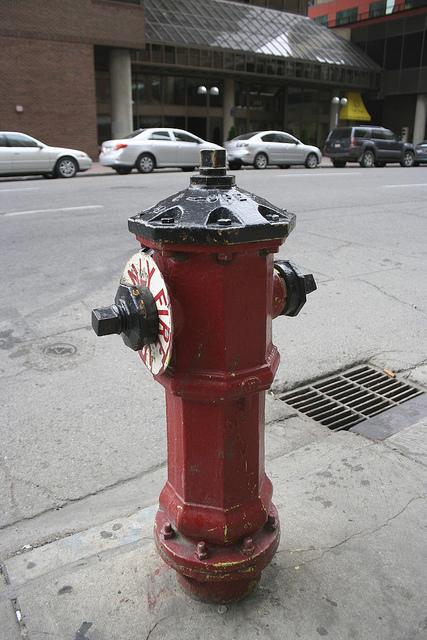What profession utilizes the red item in the foreground? firefighter 